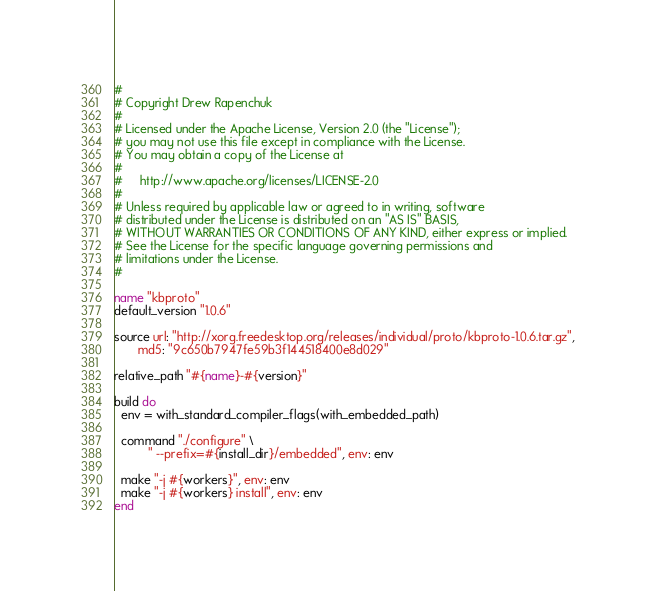Convert code to text. <code><loc_0><loc_0><loc_500><loc_500><_Ruby_>#
# Copyright Drew Rapenchuk
#
# Licensed under the Apache License, Version 2.0 (the "License");
# you may not use this file except in compliance with the License.
# You may obtain a copy of the License at
#
#     http://www.apache.org/licenses/LICENSE-2.0
#
# Unless required by applicable law or agreed to in writing, software
# distributed under the License is distributed on an "AS IS" BASIS,
# WITHOUT WARRANTIES OR CONDITIONS OF ANY KIND, either express or implied.
# See the License for the specific language governing permissions and
# limitations under the License.
#

name "kbproto"
default_version "1.0.6"

source url: "http://xorg.freedesktop.org/releases/individual/proto/kbproto-1.0.6.tar.gz",
       md5: "9c650b7947fe59b3f144518400e8d029"

relative_path "#{name}-#{version}"

build do
  env = with_standard_compiler_flags(with_embedded_path)

  command "./configure" \
          " --prefix=#{install_dir}/embedded", env: env

  make "-j #{workers}", env: env
  make "-j #{workers} install", env: env
end
</code> 